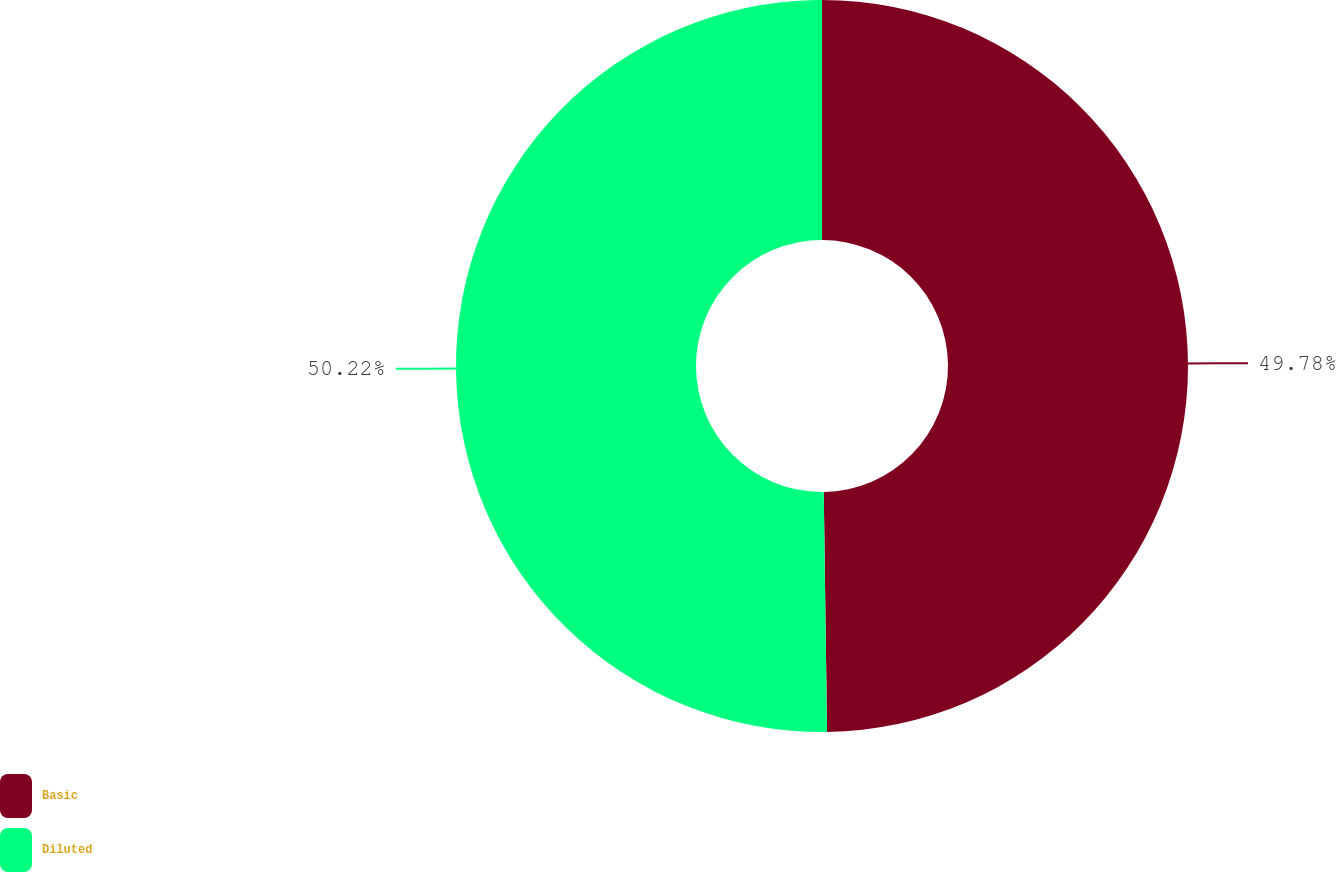<chart> <loc_0><loc_0><loc_500><loc_500><pie_chart><fcel>Basic<fcel>Diluted<nl><fcel>49.78%<fcel>50.22%<nl></chart> 